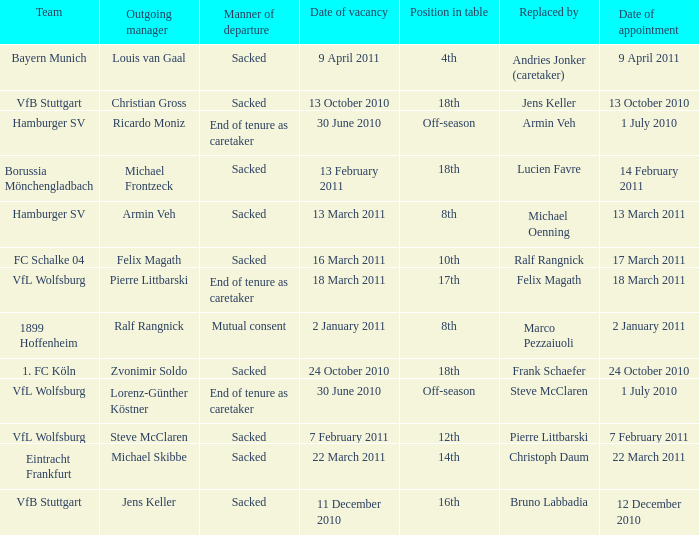When 1. fc köln is the team what is the date of appointment? 24 October 2010. 